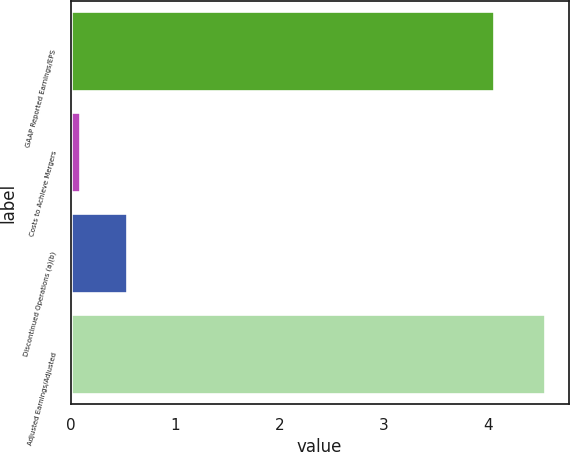Convert chart. <chart><loc_0><loc_0><loc_500><loc_500><bar_chart><fcel>GAAP Reported Earnings/EPS<fcel>Costs to Achieve Mergers<fcel>Discontinued Operations (a)(b)<fcel>Adjusted Earnings/Adjusted<nl><fcel>4.05<fcel>0.09<fcel>0.54<fcel>4.54<nl></chart> 